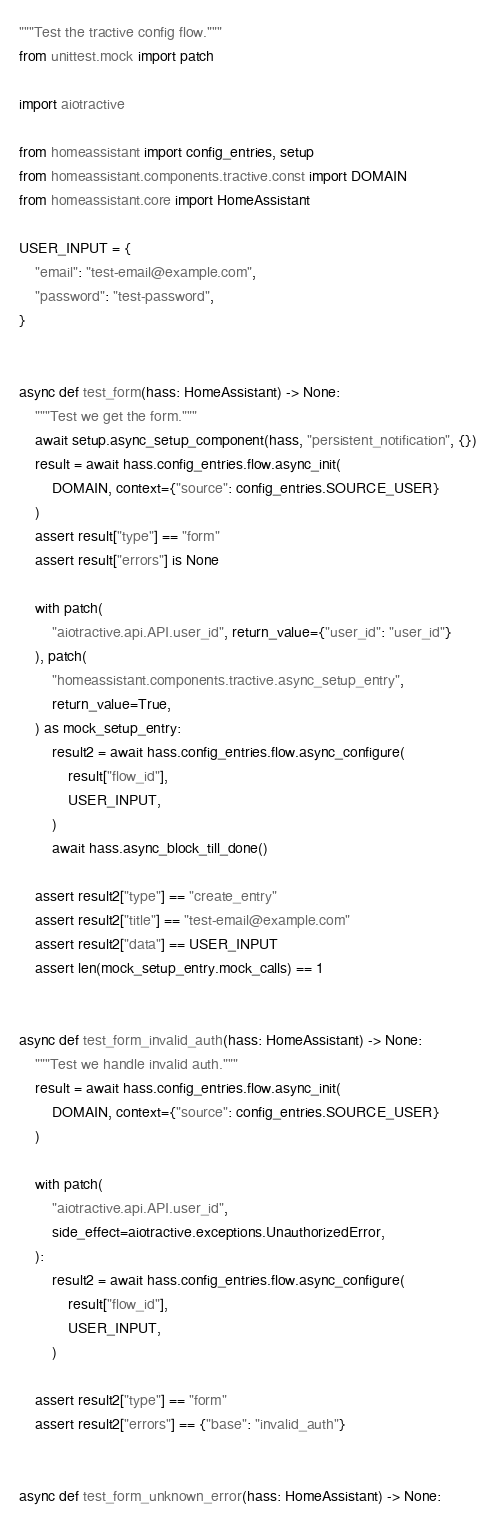<code> <loc_0><loc_0><loc_500><loc_500><_Python_>"""Test the tractive config flow."""
from unittest.mock import patch

import aiotractive

from homeassistant import config_entries, setup
from homeassistant.components.tractive.const import DOMAIN
from homeassistant.core import HomeAssistant

USER_INPUT = {
    "email": "test-email@example.com",
    "password": "test-password",
}


async def test_form(hass: HomeAssistant) -> None:
    """Test we get the form."""
    await setup.async_setup_component(hass, "persistent_notification", {})
    result = await hass.config_entries.flow.async_init(
        DOMAIN, context={"source": config_entries.SOURCE_USER}
    )
    assert result["type"] == "form"
    assert result["errors"] is None

    with patch(
        "aiotractive.api.API.user_id", return_value={"user_id": "user_id"}
    ), patch(
        "homeassistant.components.tractive.async_setup_entry",
        return_value=True,
    ) as mock_setup_entry:
        result2 = await hass.config_entries.flow.async_configure(
            result["flow_id"],
            USER_INPUT,
        )
        await hass.async_block_till_done()

    assert result2["type"] == "create_entry"
    assert result2["title"] == "test-email@example.com"
    assert result2["data"] == USER_INPUT
    assert len(mock_setup_entry.mock_calls) == 1


async def test_form_invalid_auth(hass: HomeAssistant) -> None:
    """Test we handle invalid auth."""
    result = await hass.config_entries.flow.async_init(
        DOMAIN, context={"source": config_entries.SOURCE_USER}
    )

    with patch(
        "aiotractive.api.API.user_id",
        side_effect=aiotractive.exceptions.UnauthorizedError,
    ):
        result2 = await hass.config_entries.flow.async_configure(
            result["flow_id"],
            USER_INPUT,
        )

    assert result2["type"] == "form"
    assert result2["errors"] == {"base": "invalid_auth"}


async def test_form_unknown_error(hass: HomeAssistant) -> None:</code> 